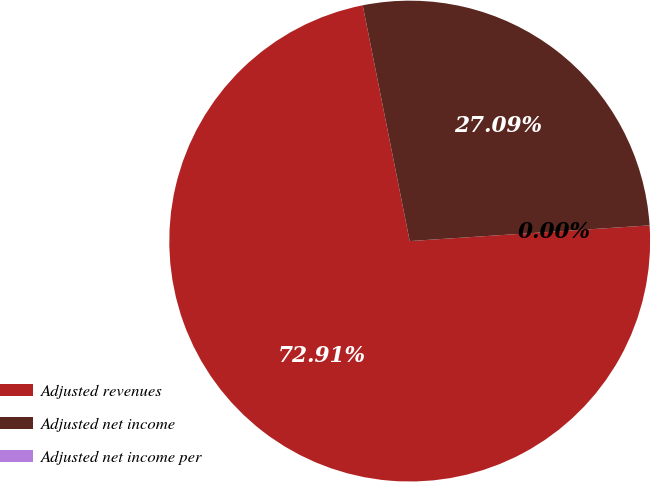<chart> <loc_0><loc_0><loc_500><loc_500><pie_chart><fcel>Adjusted revenues<fcel>Adjusted net income<fcel>Adjusted net income per<nl><fcel>72.91%<fcel>27.09%<fcel>0.0%<nl></chart> 